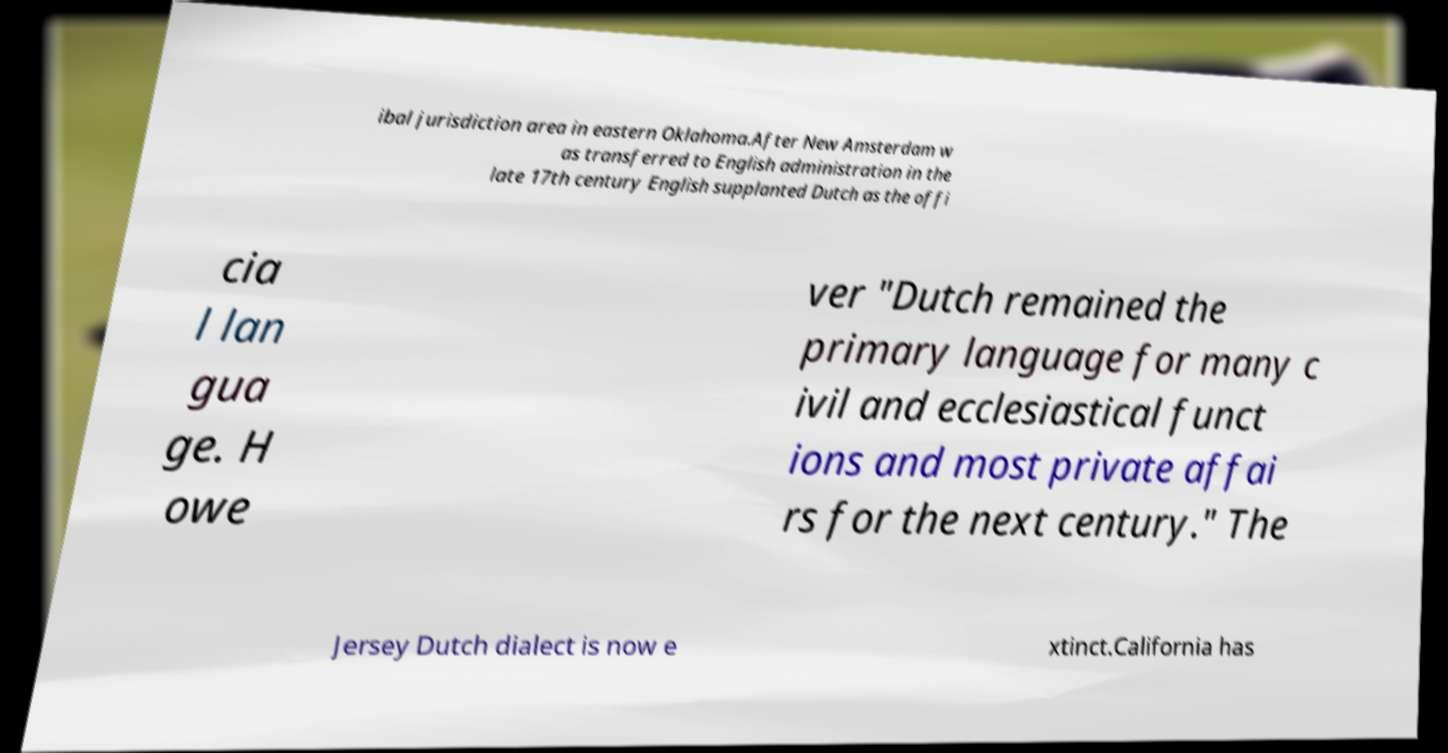Could you assist in decoding the text presented in this image and type it out clearly? ibal jurisdiction area in eastern Oklahoma.After New Amsterdam w as transferred to English administration in the late 17th century English supplanted Dutch as the offi cia l lan gua ge. H owe ver "Dutch remained the primary language for many c ivil and ecclesiastical funct ions and most private affai rs for the next century." The Jersey Dutch dialect is now e xtinct.California has 